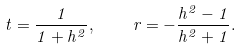Convert formula to latex. <formula><loc_0><loc_0><loc_500><loc_500>t = \frac { 1 } { 1 + h ^ { 2 } } , \quad r = - \frac { h ^ { 2 } - 1 } { h ^ { 2 } + 1 } .</formula> 